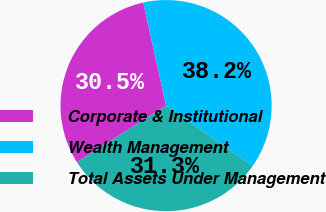Convert chart. <chart><loc_0><loc_0><loc_500><loc_500><pie_chart><fcel>Corporate & Institutional<fcel>Wealth Management<fcel>Total Assets Under Management<nl><fcel>30.53%<fcel>38.17%<fcel>31.3%<nl></chart> 